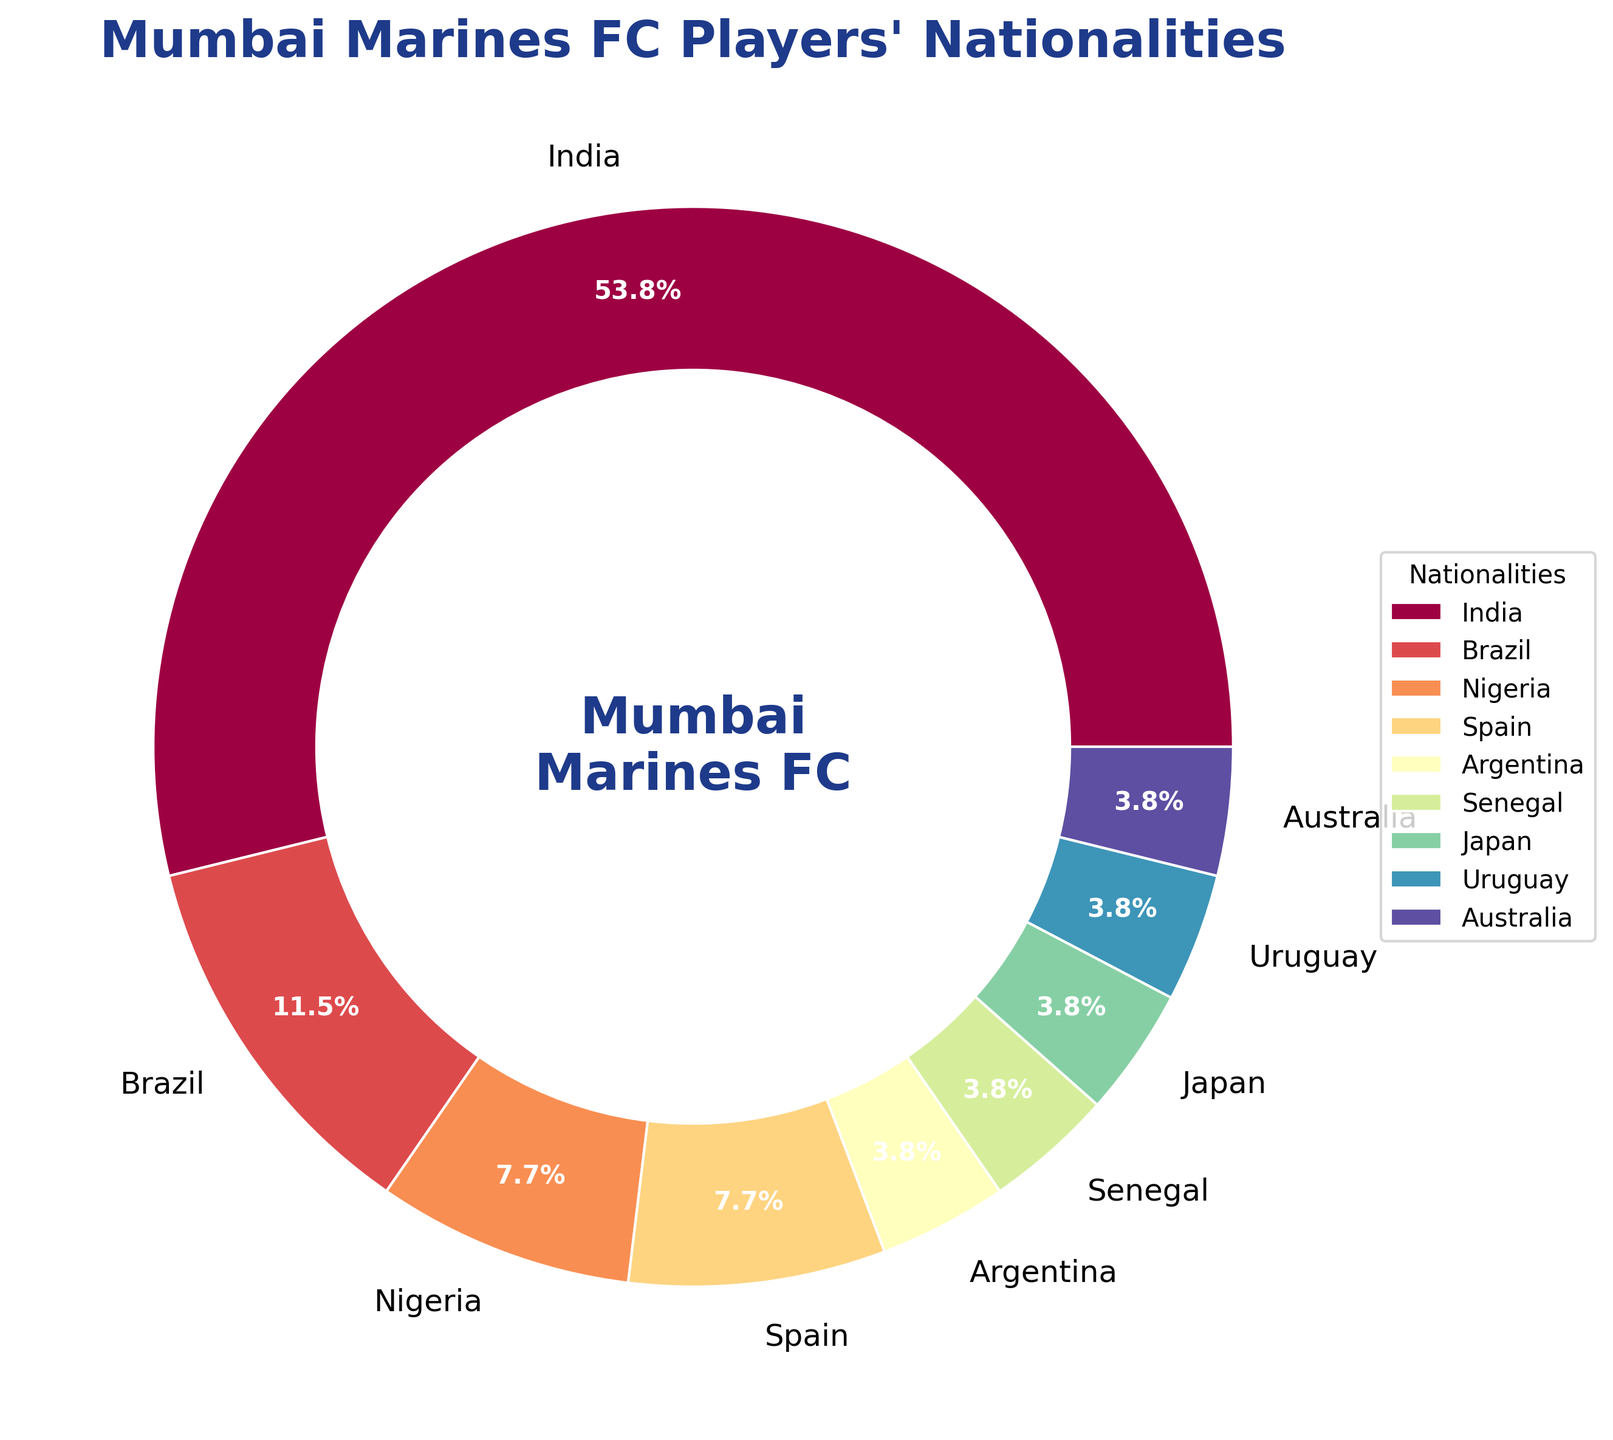What nationality has the highest number of players in the Mumbai Marines FC squad? The pie chart shows the distribution of players' nationalities. It's clear from the chart that the majority of the players are from India.
Answer: India How many more Indian players are there compared to Brazilian players? From the chart, India has 14 players, and Brazil has 3 players. The difference is 14 - 3 = 11.
Answer: 11 What percentage of the squad is made up of Asian players (India and Japan combined)? From the pie chart, there are 14 Indian players and 1 Japanese player, making a total of 14 + 1 = 15 Asian players. The total number of players is 26. The percentage is (15/26) * 100 ≈ 57.7%.
Answer: 57.7% Which nationality has the smallest number of players in the Mumbai Marines FC squad? From the chart, Argentina, Senegal, Japan, Uruguay, and Australia each have 1 player, which is the smallest number of players.
Answer: Argentina, Senegal, Japan, Uruguay, Australia What is the combined percentage of players from Nigeria and Spain? There are 2 players from Nigeria and 2 players from Spain. The total number of players is 26. The combined percentage is ((2+2)/26) * 100 ≈ 15.4%.
Answer: 15.4% How does the number of South American players (Brazil, Argentina, Uruguay) compare to the number of African players (Nigeria, Senegal)? There are 3 Brazilian players, 1 Argentinian player, and 1 Uruguayan player, making a total of 5 South American players. There are 2 Nigerian players and 1 Senegalese player, making a total of 3 African players. Therefore, there are 2 more South American players than African players.
Answer: 2 more What fraction of the squad is composed of European players? There are 2 players from Spain. The total number of players is 26. The fraction is 2/26, which simplifies to 1/13.
Answer: 1/13 Which nationality constitutes exactly 1 player in the Mumbai Marines FC squad, and what percentage do they represent? The chart shows that Argentina, Senegal, Japan, Uruguay, and Australia each have 1 player. The percentage for each is (1/26) * 100 ≈ 3.8%.
Answer: Argentina, Senegal, Japan, Uruguay, Australia; 3.8% Is the number of players from Spain greater than the number from Senegal? From the chart, Spain has 2 players, while Senegal has 1 player. Therefore, Spain has more players than Senegal.
Answer: Yes What's the average number of players for each nationality represented in the team? There are 9 nationalities represented. The total number of players is 26. The average number of players per nationality is 26/9 ≈ 2.89.
Answer: 2.89 